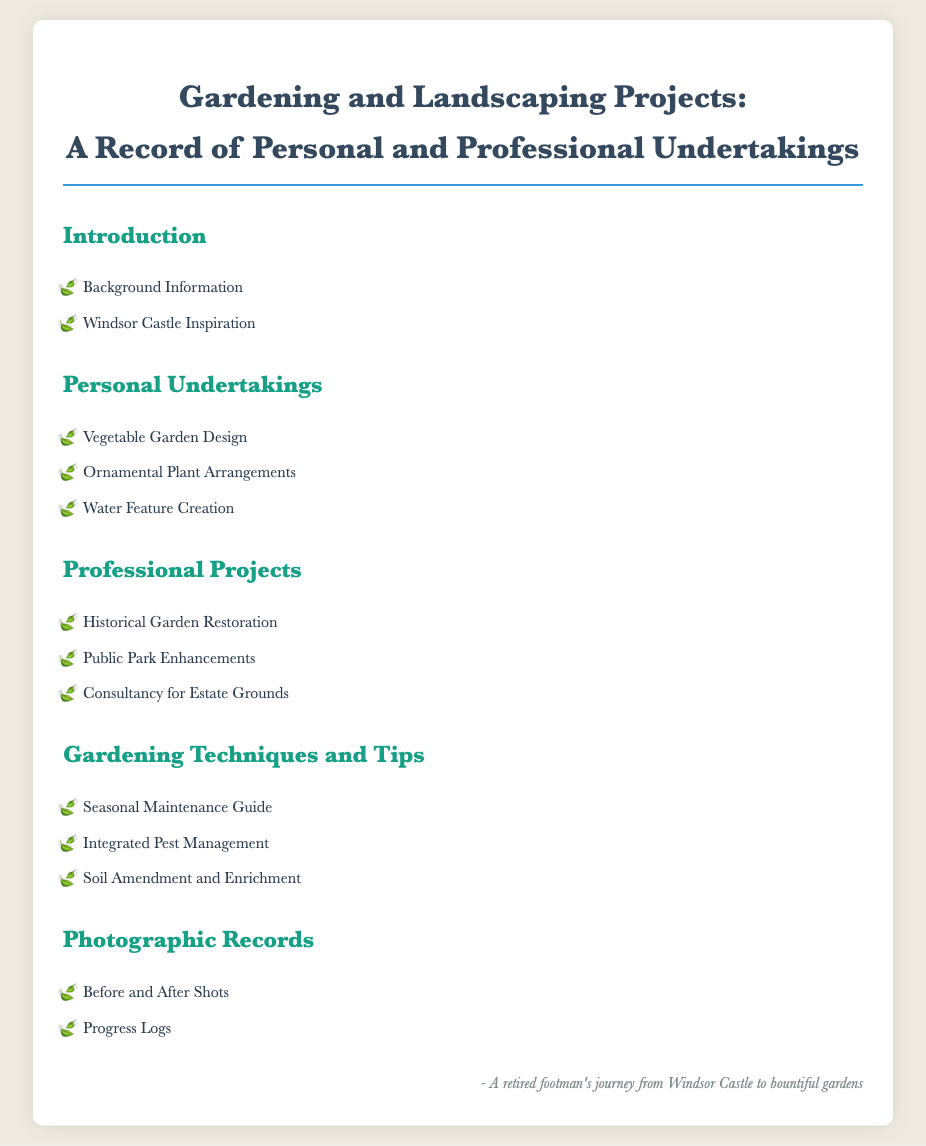what is the title of the document? The title of the document is shown at the top and indicates the main theme and content.
Answer: Gardening and Landscaping Projects: A Record of Personal and Professional Undertakings how many areas of focus are listed under Personal Undertakings? The document lists three distinct areas of focus in the Personal Undertakings section.
Answer: 3 which type of garden project involves public space? The document specifies a project that enhances gardens in public areas under Professional Projects.
Answer: Public Park Enhancements name one gardening technique mentioned in the document. The Gardening Techniques and Tips section provides several specific methods for gardening.
Answer: Integrated Pest Management who is the author as identified in the document? The document includes a signature that identifies the person's journey and experience related to gardening and landscaping.
Answer: A retired footman what visual records are included in the documentation? The Photographic Records section indicates types of visual documentation used in the context of the projects.
Answer: Before and After Shots which professional project relates to historic gardens? The Professional Projects section highlights a specific activity concerning the preservation of historical garden designs.
Answer: Historical Garden Restoration how many gardening techniques are provided? The section on Gardening Techniques and Tips lists three different techniques to help with gardening tasks.
Answer: 3 